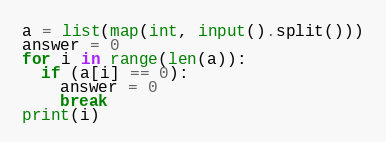Convert code to text. <code><loc_0><loc_0><loc_500><loc_500><_Python_>a = list(map(int, input().split()))
answer = 0
for i in range(len(a)):
  if (a[i] == 0):
    answer = 0
    break
print(i)</code> 